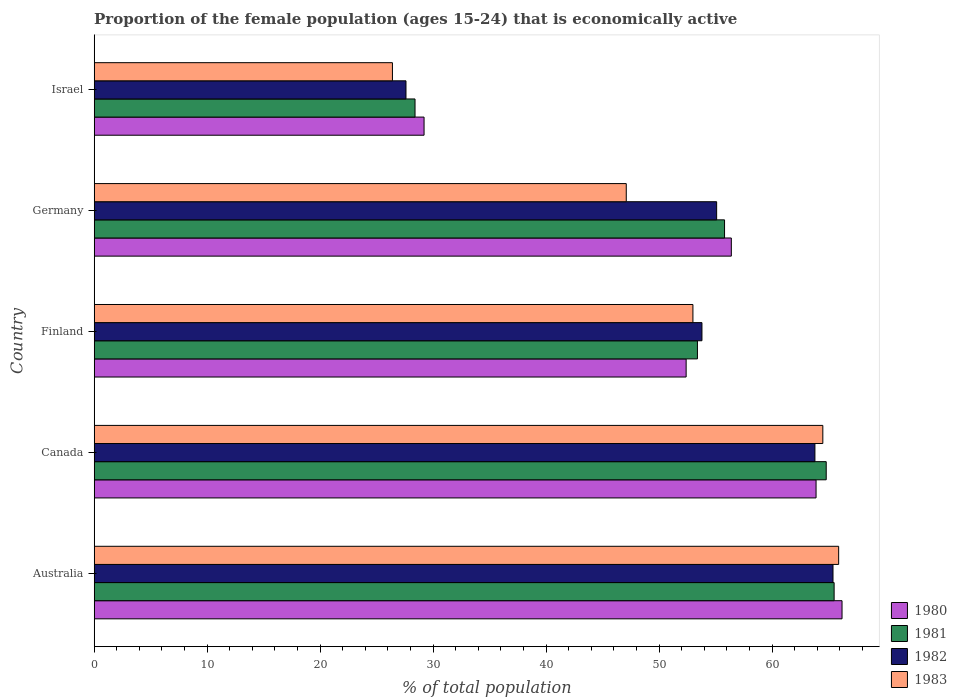How many groups of bars are there?
Offer a terse response. 5. Are the number of bars per tick equal to the number of legend labels?
Provide a short and direct response. Yes. How many bars are there on the 1st tick from the top?
Offer a very short reply. 4. How many bars are there on the 1st tick from the bottom?
Your response must be concise. 4. What is the proportion of the female population that is economically active in 1982 in Israel?
Your response must be concise. 27.6. Across all countries, what is the maximum proportion of the female population that is economically active in 1981?
Offer a terse response. 65.5. Across all countries, what is the minimum proportion of the female population that is economically active in 1981?
Give a very brief answer. 28.4. In which country was the proportion of the female population that is economically active in 1981 minimum?
Your answer should be compact. Israel. What is the total proportion of the female population that is economically active in 1980 in the graph?
Ensure brevity in your answer.  268.1. What is the difference between the proportion of the female population that is economically active in 1981 in Canada and that in Israel?
Keep it short and to the point. 36.4. What is the difference between the proportion of the female population that is economically active in 1981 in Israel and the proportion of the female population that is economically active in 1980 in Canada?
Your answer should be compact. -35.5. What is the average proportion of the female population that is economically active in 1980 per country?
Your answer should be very brief. 53.62. What is the difference between the proportion of the female population that is economically active in 1982 and proportion of the female population that is economically active in 1983 in Canada?
Keep it short and to the point. -0.7. What is the ratio of the proportion of the female population that is economically active in 1982 in Australia to that in Germany?
Provide a succinct answer. 1.19. Is the difference between the proportion of the female population that is economically active in 1982 in Germany and Israel greater than the difference between the proportion of the female population that is economically active in 1983 in Germany and Israel?
Provide a succinct answer. Yes. What is the difference between the highest and the second highest proportion of the female population that is economically active in 1982?
Give a very brief answer. 1.6. What is the difference between the highest and the lowest proportion of the female population that is economically active in 1983?
Offer a very short reply. 39.5. Is the sum of the proportion of the female population that is economically active in 1980 in Australia and Canada greater than the maximum proportion of the female population that is economically active in 1982 across all countries?
Your answer should be compact. Yes. How many bars are there?
Offer a terse response. 20. How many countries are there in the graph?
Your answer should be compact. 5. What is the difference between two consecutive major ticks on the X-axis?
Keep it short and to the point. 10. Does the graph contain any zero values?
Your response must be concise. No. Where does the legend appear in the graph?
Your answer should be compact. Bottom right. How are the legend labels stacked?
Provide a succinct answer. Vertical. What is the title of the graph?
Provide a short and direct response. Proportion of the female population (ages 15-24) that is economically active. What is the label or title of the X-axis?
Give a very brief answer. % of total population. What is the label or title of the Y-axis?
Offer a terse response. Country. What is the % of total population in 1980 in Australia?
Provide a succinct answer. 66.2. What is the % of total population of 1981 in Australia?
Your answer should be compact. 65.5. What is the % of total population in 1982 in Australia?
Offer a very short reply. 65.4. What is the % of total population of 1983 in Australia?
Your answer should be compact. 65.9. What is the % of total population of 1980 in Canada?
Ensure brevity in your answer.  63.9. What is the % of total population in 1981 in Canada?
Offer a terse response. 64.8. What is the % of total population in 1982 in Canada?
Offer a terse response. 63.8. What is the % of total population in 1983 in Canada?
Provide a short and direct response. 64.5. What is the % of total population in 1980 in Finland?
Make the answer very short. 52.4. What is the % of total population of 1981 in Finland?
Your answer should be compact. 53.4. What is the % of total population of 1982 in Finland?
Your response must be concise. 53.8. What is the % of total population in 1983 in Finland?
Ensure brevity in your answer.  53. What is the % of total population in 1980 in Germany?
Provide a succinct answer. 56.4. What is the % of total population in 1981 in Germany?
Your answer should be compact. 55.8. What is the % of total population of 1982 in Germany?
Your response must be concise. 55.1. What is the % of total population in 1983 in Germany?
Provide a succinct answer. 47.1. What is the % of total population in 1980 in Israel?
Your answer should be compact. 29.2. What is the % of total population of 1981 in Israel?
Your answer should be compact. 28.4. What is the % of total population in 1982 in Israel?
Keep it short and to the point. 27.6. What is the % of total population in 1983 in Israel?
Your answer should be compact. 26.4. Across all countries, what is the maximum % of total population in 1980?
Your answer should be very brief. 66.2. Across all countries, what is the maximum % of total population of 1981?
Your response must be concise. 65.5. Across all countries, what is the maximum % of total population in 1982?
Your response must be concise. 65.4. Across all countries, what is the maximum % of total population in 1983?
Offer a very short reply. 65.9. Across all countries, what is the minimum % of total population in 1980?
Make the answer very short. 29.2. Across all countries, what is the minimum % of total population of 1981?
Your answer should be very brief. 28.4. Across all countries, what is the minimum % of total population of 1982?
Offer a very short reply. 27.6. Across all countries, what is the minimum % of total population in 1983?
Provide a succinct answer. 26.4. What is the total % of total population of 1980 in the graph?
Ensure brevity in your answer.  268.1. What is the total % of total population in 1981 in the graph?
Offer a terse response. 267.9. What is the total % of total population in 1982 in the graph?
Make the answer very short. 265.7. What is the total % of total population in 1983 in the graph?
Offer a very short reply. 256.9. What is the difference between the % of total population of 1982 in Australia and that in Canada?
Your answer should be very brief. 1.6. What is the difference between the % of total population of 1983 in Australia and that in Canada?
Your answer should be compact. 1.4. What is the difference between the % of total population of 1982 in Australia and that in Finland?
Your answer should be very brief. 11.6. What is the difference between the % of total population of 1980 in Australia and that in Germany?
Your answer should be very brief. 9.8. What is the difference between the % of total population in 1981 in Australia and that in Germany?
Offer a terse response. 9.7. What is the difference between the % of total population of 1982 in Australia and that in Germany?
Provide a succinct answer. 10.3. What is the difference between the % of total population in 1981 in Australia and that in Israel?
Give a very brief answer. 37.1. What is the difference between the % of total population in 1982 in Australia and that in Israel?
Provide a short and direct response. 37.8. What is the difference between the % of total population in 1983 in Australia and that in Israel?
Keep it short and to the point. 39.5. What is the difference between the % of total population of 1980 in Canada and that in Finland?
Your answer should be compact. 11.5. What is the difference between the % of total population of 1983 in Canada and that in Finland?
Provide a succinct answer. 11.5. What is the difference between the % of total population of 1980 in Canada and that in Germany?
Make the answer very short. 7.5. What is the difference between the % of total population of 1982 in Canada and that in Germany?
Your response must be concise. 8.7. What is the difference between the % of total population of 1980 in Canada and that in Israel?
Provide a succinct answer. 34.7. What is the difference between the % of total population in 1981 in Canada and that in Israel?
Provide a short and direct response. 36.4. What is the difference between the % of total population of 1982 in Canada and that in Israel?
Ensure brevity in your answer.  36.2. What is the difference between the % of total population of 1983 in Canada and that in Israel?
Provide a short and direct response. 38.1. What is the difference between the % of total population of 1983 in Finland and that in Germany?
Give a very brief answer. 5.9. What is the difference between the % of total population in 1980 in Finland and that in Israel?
Your response must be concise. 23.2. What is the difference between the % of total population in 1982 in Finland and that in Israel?
Provide a succinct answer. 26.2. What is the difference between the % of total population of 1983 in Finland and that in Israel?
Provide a short and direct response. 26.6. What is the difference between the % of total population in 1980 in Germany and that in Israel?
Keep it short and to the point. 27.2. What is the difference between the % of total population in 1981 in Germany and that in Israel?
Provide a succinct answer. 27.4. What is the difference between the % of total population of 1983 in Germany and that in Israel?
Provide a short and direct response. 20.7. What is the difference between the % of total population of 1980 in Australia and the % of total population of 1981 in Canada?
Your answer should be compact. 1.4. What is the difference between the % of total population in 1980 in Australia and the % of total population in 1982 in Canada?
Your response must be concise. 2.4. What is the difference between the % of total population in 1980 in Australia and the % of total population in 1983 in Canada?
Give a very brief answer. 1.7. What is the difference between the % of total population in 1982 in Australia and the % of total population in 1983 in Canada?
Offer a very short reply. 0.9. What is the difference between the % of total population in 1980 in Australia and the % of total population in 1981 in Finland?
Give a very brief answer. 12.8. What is the difference between the % of total population of 1980 in Australia and the % of total population of 1983 in Finland?
Your response must be concise. 13.2. What is the difference between the % of total population of 1981 in Australia and the % of total population of 1982 in Finland?
Ensure brevity in your answer.  11.7. What is the difference between the % of total population in 1982 in Australia and the % of total population in 1983 in Finland?
Give a very brief answer. 12.4. What is the difference between the % of total population of 1980 in Australia and the % of total population of 1981 in Germany?
Your answer should be very brief. 10.4. What is the difference between the % of total population in 1980 in Australia and the % of total population in 1981 in Israel?
Give a very brief answer. 37.8. What is the difference between the % of total population of 1980 in Australia and the % of total population of 1982 in Israel?
Make the answer very short. 38.6. What is the difference between the % of total population of 1980 in Australia and the % of total population of 1983 in Israel?
Make the answer very short. 39.8. What is the difference between the % of total population of 1981 in Australia and the % of total population of 1982 in Israel?
Ensure brevity in your answer.  37.9. What is the difference between the % of total population of 1981 in Australia and the % of total population of 1983 in Israel?
Offer a very short reply. 39.1. What is the difference between the % of total population in 1982 in Australia and the % of total population in 1983 in Israel?
Keep it short and to the point. 39. What is the difference between the % of total population in 1980 in Canada and the % of total population in 1981 in Finland?
Your answer should be compact. 10.5. What is the difference between the % of total population of 1980 in Canada and the % of total population of 1982 in Finland?
Offer a very short reply. 10.1. What is the difference between the % of total population of 1981 in Canada and the % of total population of 1982 in Finland?
Make the answer very short. 11. What is the difference between the % of total population in 1981 in Canada and the % of total population in 1983 in Finland?
Your answer should be compact. 11.8. What is the difference between the % of total population of 1980 in Canada and the % of total population of 1981 in Germany?
Offer a terse response. 8.1. What is the difference between the % of total population in 1980 in Canada and the % of total population in 1982 in Germany?
Offer a very short reply. 8.8. What is the difference between the % of total population of 1980 in Canada and the % of total population of 1983 in Germany?
Ensure brevity in your answer.  16.8. What is the difference between the % of total population in 1982 in Canada and the % of total population in 1983 in Germany?
Offer a terse response. 16.7. What is the difference between the % of total population of 1980 in Canada and the % of total population of 1981 in Israel?
Provide a succinct answer. 35.5. What is the difference between the % of total population of 1980 in Canada and the % of total population of 1982 in Israel?
Provide a short and direct response. 36.3. What is the difference between the % of total population in 1980 in Canada and the % of total population in 1983 in Israel?
Keep it short and to the point. 37.5. What is the difference between the % of total population of 1981 in Canada and the % of total population of 1982 in Israel?
Your answer should be very brief. 37.2. What is the difference between the % of total population in 1981 in Canada and the % of total population in 1983 in Israel?
Provide a succinct answer. 38.4. What is the difference between the % of total population of 1982 in Canada and the % of total population of 1983 in Israel?
Keep it short and to the point. 37.4. What is the difference between the % of total population of 1980 in Finland and the % of total population of 1981 in Germany?
Offer a terse response. -3.4. What is the difference between the % of total population in 1980 in Finland and the % of total population in 1983 in Germany?
Your answer should be very brief. 5.3. What is the difference between the % of total population of 1981 in Finland and the % of total population of 1982 in Germany?
Offer a very short reply. -1.7. What is the difference between the % of total population of 1980 in Finland and the % of total population of 1982 in Israel?
Give a very brief answer. 24.8. What is the difference between the % of total population of 1981 in Finland and the % of total population of 1982 in Israel?
Your response must be concise. 25.8. What is the difference between the % of total population of 1982 in Finland and the % of total population of 1983 in Israel?
Offer a very short reply. 27.4. What is the difference between the % of total population of 1980 in Germany and the % of total population of 1981 in Israel?
Give a very brief answer. 28. What is the difference between the % of total population of 1980 in Germany and the % of total population of 1982 in Israel?
Offer a very short reply. 28.8. What is the difference between the % of total population in 1981 in Germany and the % of total population in 1982 in Israel?
Offer a terse response. 28.2. What is the difference between the % of total population in 1981 in Germany and the % of total population in 1983 in Israel?
Your answer should be very brief. 29.4. What is the difference between the % of total population of 1982 in Germany and the % of total population of 1983 in Israel?
Provide a short and direct response. 28.7. What is the average % of total population in 1980 per country?
Keep it short and to the point. 53.62. What is the average % of total population in 1981 per country?
Provide a short and direct response. 53.58. What is the average % of total population of 1982 per country?
Ensure brevity in your answer.  53.14. What is the average % of total population of 1983 per country?
Offer a very short reply. 51.38. What is the difference between the % of total population of 1981 and % of total population of 1983 in Australia?
Provide a short and direct response. -0.4. What is the difference between the % of total population of 1982 and % of total population of 1983 in Australia?
Your answer should be compact. -0.5. What is the difference between the % of total population in 1980 and % of total population in 1981 in Canada?
Provide a short and direct response. -0.9. What is the difference between the % of total population in 1980 and % of total population in 1982 in Canada?
Keep it short and to the point. 0.1. What is the difference between the % of total population of 1980 and % of total population of 1983 in Canada?
Offer a terse response. -0.6. What is the difference between the % of total population of 1981 and % of total population of 1983 in Canada?
Your response must be concise. 0.3. What is the difference between the % of total population of 1982 and % of total population of 1983 in Canada?
Offer a very short reply. -0.7. What is the difference between the % of total population in 1980 and % of total population in 1981 in Finland?
Your response must be concise. -1. What is the difference between the % of total population in 1980 and % of total population in 1982 in Finland?
Give a very brief answer. -1.4. What is the difference between the % of total population of 1981 and % of total population of 1982 in Finland?
Your answer should be very brief. -0.4. What is the difference between the % of total population in 1981 and % of total population in 1983 in Finland?
Your answer should be very brief. 0.4. What is the difference between the % of total population in 1980 and % of total population in 1981 in Germany?
Give a very brief answer. 0.6. What is the difference between the % of total population in 1980 and % of total population in 1982 in Germany?
Offer a terse response. 1.3. What is the difference between the % of total population of 1982 and % of total population of 1983 in Germany?
Make the answer very short. 8. What is the difference between the % of total population of 1980 and % of total population of 1981 in Israel?
Give a very brief answer. 0.8. What is the difference between the % of total population in 1980 and % of total population in 1983 in Israel?
Offer a very short reply. 2.8. What is the ratio of the % of total population in 1980 in Australia to that in Canada?
Keep it short and to the point. 1.04. What is the ratio of the % of total population in 1981 in Australia to that in Canada?
Offer a terse response. 1.01. What is the ratio of the % of total population in 1982 in Australia to that in Canada?
Offer a very short reply. 1.03. What is the ratio of the % of total population of 1983 in Australia to that in Canada?
Your answer should be very brief. 1.02. What is the ratio of the % of total population of 1980 in Australia to that in Finland?
Provide a succinct answer. 1.26. What is the ratio of the % of total population of 1981 in Australia to that in Finland?
Keep it short and to the point. 1.23. What is the ratio of the % of total population of 1982 in Australia to that in Finland?
Keep it short and to the point. 1.22. What is the ratio of the % of total population of 1983 in Australia to that in Finland?
Offer a terse response. 1.24. What is the ratio of the % of total population in 1980 in Australia to that in Germany?
Offer a very short reply. 1.17. What is the ratio of the % of total population in 1981 in Australia to that in Germany?
Offer a very short reply. 1.17. What is the ratio of the % of total population in 1982 in Australia to that in Germany?
Give a very brief answer. 1.19. What is the ratio of the % of total population of 1983 in Australia to that in Germany?
Your response must be concise. 1.4. What is the ratio of the % of total population of 1980 in Australia to that in Israel?
Provide a succinct answer. 2.27. What is the ratio of the % of total population of 1981 in Australia to that in Israel?
Keep it short and to the point. 2.31. What is the ratio of the % of total population in 1982 in Australia to that in Israel?
Your response must be concise. 2.37. What is the ratio of the % of total population in 1983 in Australia to that in Israel?
Offer a very short reply. 2.5. What is the ratio of the % of total population of 1980 in Canada to that in Finland?
Offer a very short reply. 1.22. What is the ratio of the % of total population of 1981 in Canada to that in Finland?
Make the answer very short. 1.21. What is the ratio of the % of total population of 1982 in Canada to that in Finland?
Provide a succinct answer. 1.19. What is the ratio of the % of total population in 1983 in Canada to that in Finland?
Your response must be concise. 1.22. What is the ratio of the % of total population in 1980 in Canada to that in Germany?
Offer a terse response. 1.13. What is the ratio of the % of total population of 1981 in Canada to that in Germany?
Provide a short and direct response. 1.16. What is the ratio of the % of total population in 1982 in Canada to that in Germany?
Offer a very short reply. 1.16. What is the ratio of the % of total population in 1983 in Canada to that in Germany?
Keep it short and to the point. 1.37. What is the ratio of the % of total population of 1980 in Canada to that in Israel?
Keep it short and to the point. 2.19. What is the ratio of the % of total population of 1981 in Canada to that in Israel?
Offer a terse response. 2.28. What is the ratio of the % of total population of 1982 in Canada to that in Israel?
Your answer should be very brief. 2.31. What is the ratio of the % of total population of 1983 in Canada to that in Israel?
Keep it short and to the point. 2.44. What is the ratio of the % of total population in 1980 in Finland to that in Germany?
Offer a terse response. 0.93. What is the ratio of the % of total population in 1982 in Finland to that in Germany?
Ensure brevity in your answer.  0.98. What is the ratio of the % of total population of 1983 in Finland to that in Germany?
Provide a succinct answer. 1.13. What is the ratio of the % of total population in 1980 in Finland to that in Israel?
Your response must be concise. 1.79. What is the ratio of the % of total population in 1981 in Finland to that in Israel?
Ensure brevity in your answer.  1.88. What is the ratio of the % of total population of 1982 in Finland to that in Israel?
Make the answer very short. 1.95. What is the ratio of the % of total population of 1983 in Finland to that in Israel?
Your response must be concise. 2.01. What is the ratio of the % of total population of 1980 in Germany to that in Israel?
Give a very brief answer. 1.93. What is the ratio of the % of total population in 1981 in Germany to that in Israel?
Provide a short and direct response. 1.96. What is the ratio of the % of total population in 1982 in Germany to that in Israel?
Your response must be concise. 2. What is the ratio of the % of total population in 1983 in Germany to that in Israel?
Make the answer very short. 1.78. What is the difference between the highest and the second highest % of total population of 1980?
Give a very brief answer. 2.3. What is the difference between the highest and the second highest % of total population of 1981?
Give a very brief answer. 0.7. What is the difference between the highest and the second highest % of total population of 1982?
Make the answer very short. 1.6. What is the difference between the highest and the lowest % of total population in 1981?
Your response must be concise. 37.1. What is the difference between the highest and the lowest % of total population of 1982?
Your answer should be very brief. 37.8. What is the difference between the highest and the lowest % of total population of 1983?
Make the answer very short. 39.5. 